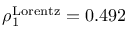Convert formula to latex. <formula><loc_0><loc_0><loc_500><loc_500>\rho _ { 1 } ^ { L o r e n t z } = 0 . 4 9 2</formula> 